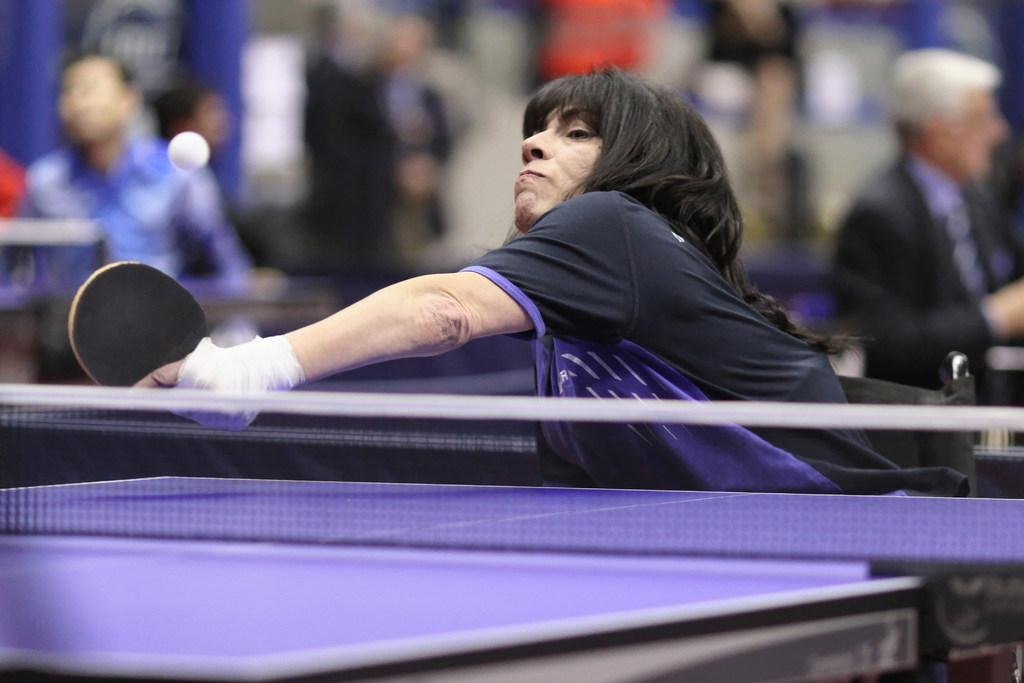Who is the main subject in the image? There is a woman in the image. What is the woman holding in her hands? The woman is holding a racket in her hands. Can you describe the background of the image? There are persons standing in the background of the image, and there is a ball in the air. What type of dirt can be seen on the woman's shoes in the image? There is no dirt visible on the woman's shoes in the image. What reward is the woman receiving for her performance in the image? There is no reward being given in the image; the woman is simply holding a racket. 